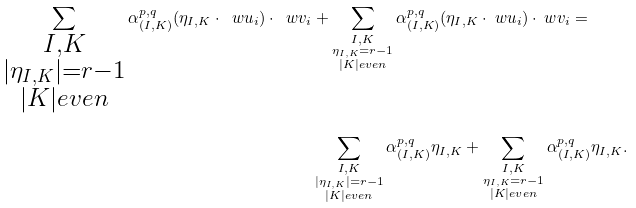Convert formula to latex. <formula><loc_0><loc_0><loc_500><loc_500>\sum _ { \substack { { I , K } \\ { | \eta _ { I , K } | = r - 1 } \\ { | K | e v e n } } } \alpha ^ { p , q } _ { ( I , K ) } ( \eta _ { I , K } \cdot \ w u _ { i } ) \cdot \ w v _ { i } & + \sum _ { \substack { { I , K } \\ { \eta _ { I , K } = r - 1 } \\ { | K | e v e n } } } \alpha ^ { p , q } _ { ( I , K ) } ( \eta _ { I , K } \cdot \ w u _ { i } ) \cdot \ w v _ { i } = \\ & \sum _ { \substack { { I , K } \\ { | \eta _ { I , K } | = r - 1 } \\ { | K | e v e n } } } \alpha ^ { p , q } _ { ( I , K ) } \eta _ { I , K } + \sum _ { \substack { { I , K } \\ { \eta _ { I , K } = r - 1 } \\ { | K | e v e n } } } \alpha ^ { p , q } _ { ( I , K ) } \eta _ { I , K } .</formula> 